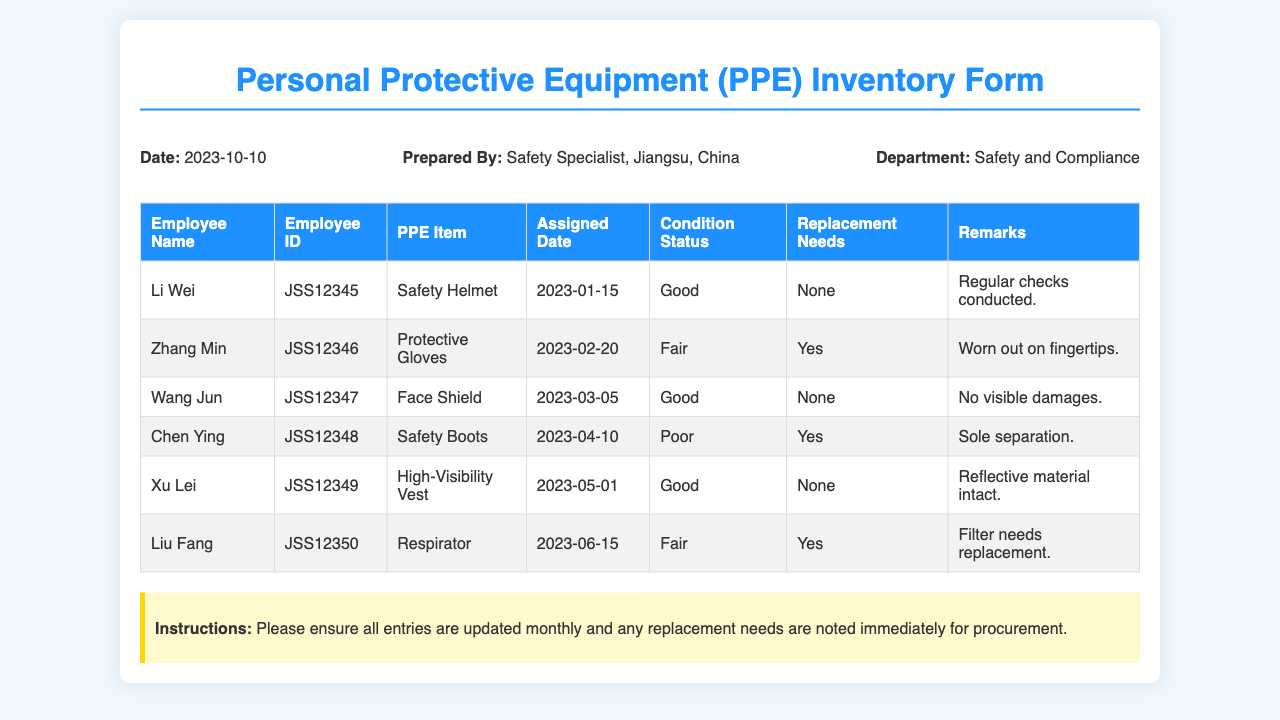What is the date of the PPE inventory form? The date is stated in the header of the document, indicating when the form was prepared.
Answer: 2023-10-10 Who prepared the PPE inventory form? The name of the person who prepared the form is listed in the header information.
Answer: Safety Specialist, Jiangsu, China What is the condition status of Protective Gloves? The condition status is reported in the PPE item table for Protective Gloves.
Answer: Fair Which PPE item assigned to Chen Ying needs replacement? The replacement needs are specified in the table for Safety Boots assigned to Chen Ying.
Answer: Yes What is the Employee ID of Li Wei? The Employee ID for Li Wei is noted in the inventory table next to his name.
Answer: JSS12345 How many PPE items are listed as in "Good" condition? The number of items in "Good" condition is counted from the condition status column in the table.
Answer: 3 What remarks are noted for the Respirator? The remarks section in the PPE inventory table provides additional details regarding the condition of the Respirator.
Answer: Filter needs replacement What is the assigned date of the Face Shield? The assigned date can be found in the corresponding row under the column for Assigned Date in the inventory table.
Answer: 2023-03-05 Which PPE item does Xu Lei have assigned? The specific PPE item assigned to Xu Lei is recorded in the PPE item column of the table.
Answer: High-Visibility Vest 